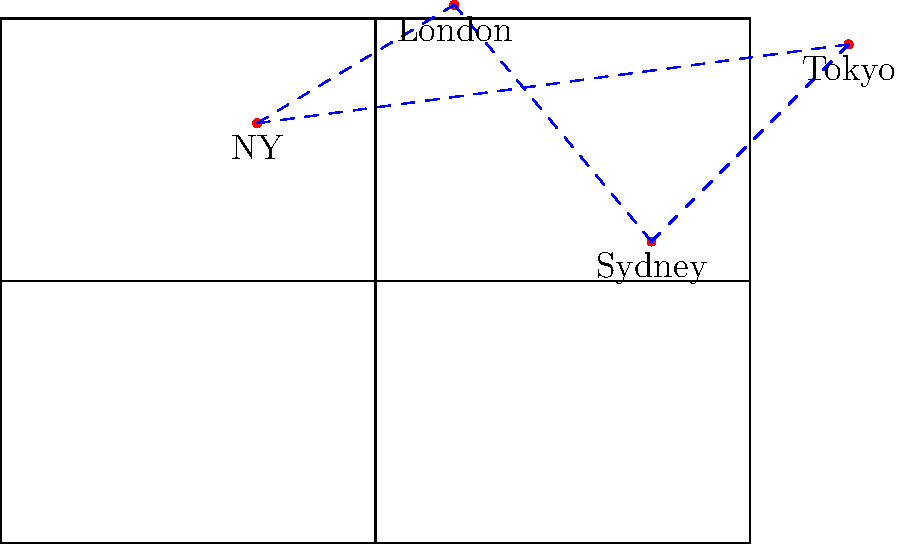As the Nobel laureate's schedule manager, you're planning their global speaking tour. Given the world map with pinpointed locations and connections, what is the total number of unique routes the laureate can take to visit all four cities exactly once, starting and ending in New York? To solve this problem, we need to follow these steps:

1. Identify the cities: New York (NY), London, Sydney, and Tokyo.

2. Understand the constraint: The tour must start and end in New York, visiting each other city exactly once.

3. Calculate the number of possible routes:
   - From NY, we have 3 choices for the first city.
   - For the second city, we have 2 remaining choices.
   - For the third city, only 1 choice is left.
   - The tour must return to NY at the end.

4. Apply the multiplication principle:
   Number of routes = $3 \times 2 \times 1 = 6$

5. List all possible routes:
   a) NY → London → Sydney → Tokyo → NY
   b) NY → London → Tokyo → Sydney → NY
   c) NY → Sydney → London → Tokyo → NY
   d) NY → Sydney → Tokyo → London → NY
   e) NY → Tokyo → London → Sydney → NY
   f) NY → Tokyo → Sydney → London → NY

Therefore, there are 6 unique routes the Nobel laureate can take to visit all four cities exactly once, starting and ending in New York.
Answer: 6 routes 